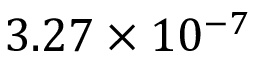Convert formula to latex. <formula><loc_0><loc_0><loc_500><loc_500>3 . 2 7 \times 1 0 ^ { - 7 }</formula> 